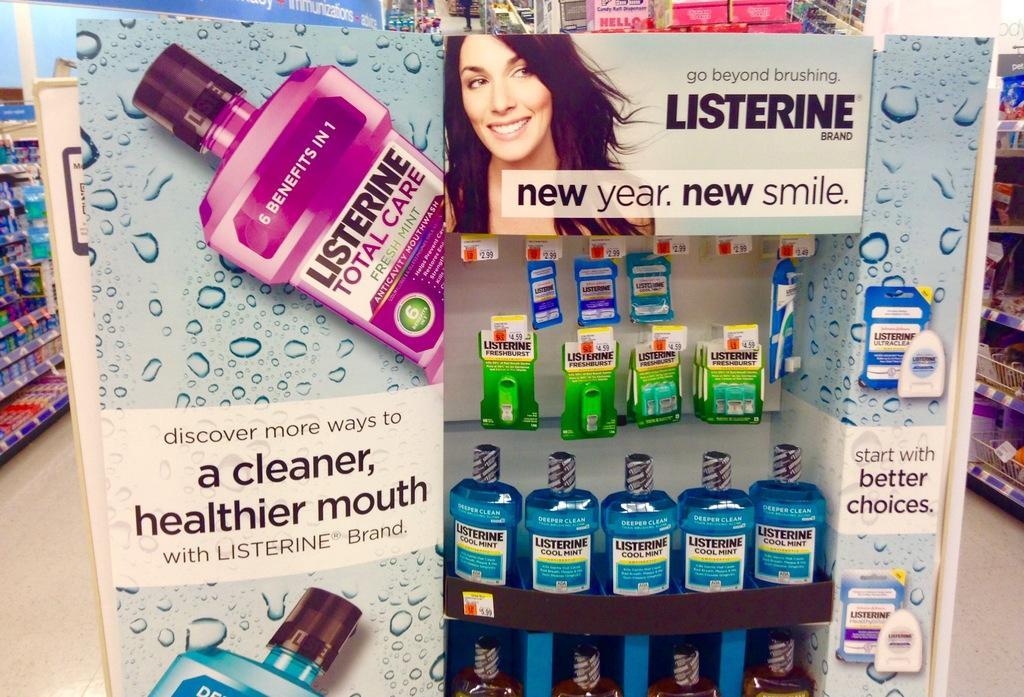How many benefits does the mouthwash have?
Make the answer very short. 6. What is the brand in the display?
Give a very brief answer. Listerine. On the purple bottle what are the top words?
Make the answer very short. 6 benefits in 1. 